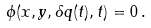Convert formula to latex. <formula><loc_0><loc_0><loc_500><loc_500>\phi ( x , y , \delta q ( t ) , t ) = 0 \, .</formula> 